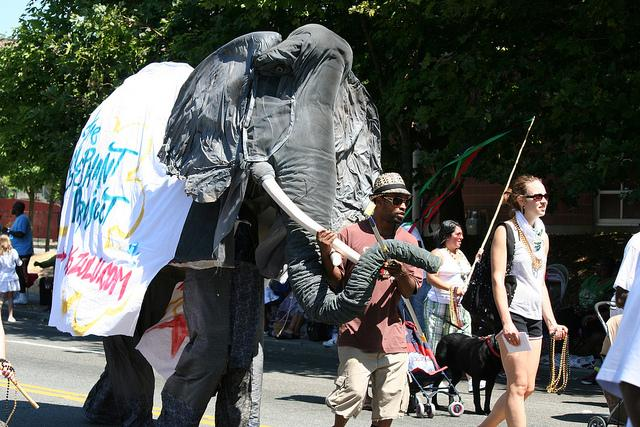What is the ancestral animal of the animal represented here?

Choices:
A) woolly mammoth
B) lion
C) asian elephant
D) tiger woolly mammoth 